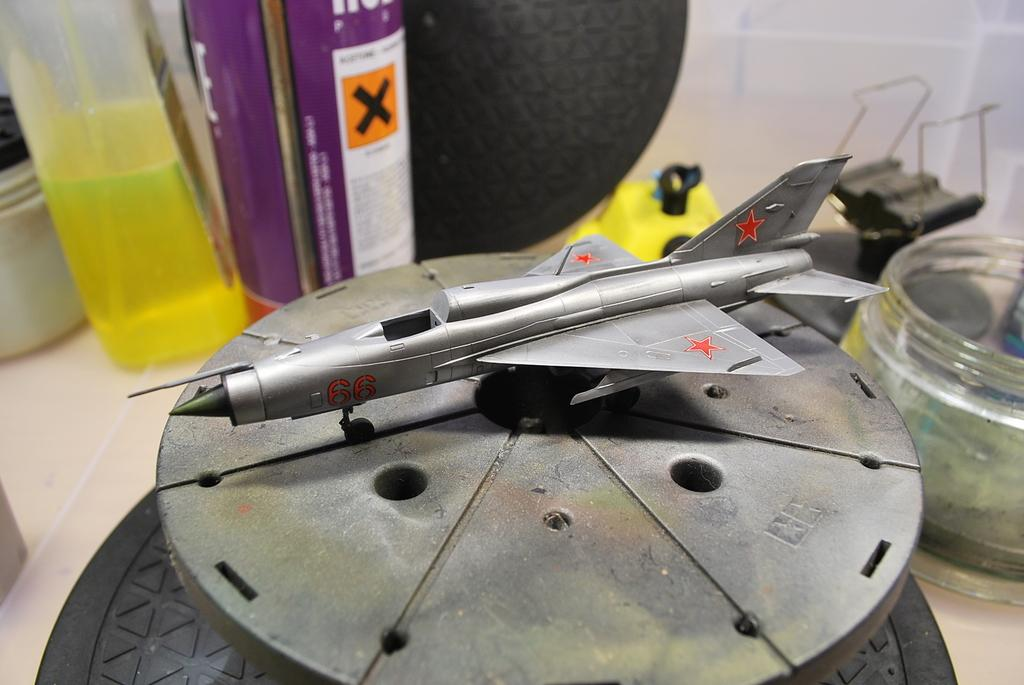What is the main subject in the middle of the image? There is a miniature of a plane in the middle of the image. What can be seen in the background of the image? There are bottles and other things visible in the background of the image. Can you describe the contents of the bottles? At least one of the bottles contains liquid. How does the beggar interact with the butter in the image? There is no beggar or butter present in the image. 